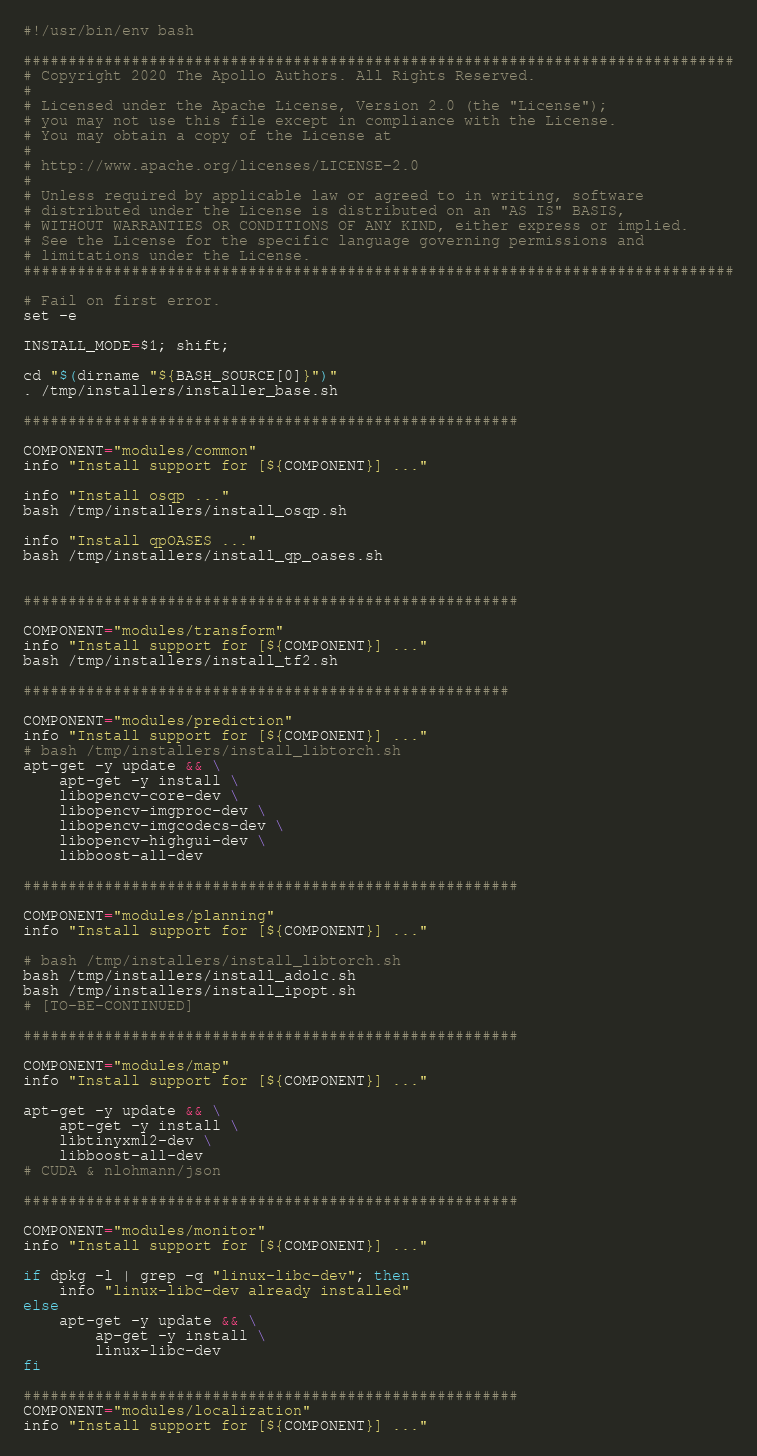<code> <loc_0><loc_0><loc_500><loc_500><_Bash_>#!/usr/bin/env bash

###############################################################################
# Copyright 2020 The Apollo Authors. All Rights Reserved.
#
# Licensed under the Apache License, Version 2.0 (the "License");
# you may not use this file except in compliance with the License.
# You may obtain a copy of the License at
#
# http://www.apache.org/licenses/LICENSE-2.0
#
# Unless required by applicable law or agreed to in writing, software
# distributed under the License is distributed on an "AS IS" BASIS,
# WITHOUT WARRANTIES OR CONDITIONS OF ANY KIND, either express or implied.
# See the License for the specific language governing permissions and
# limitations under the License.
###############################################################################

# Fail on first error.
set -e

INSTALL_MODE=$1; shift;

cd "$(dirname "${BASH_SOURCE[0]}")"
. /tmp/installers/installer_base.sh

#######################################################

COMPONENT="modules/common"
info "Install support for [${COMPONENT}] ..."

info "Install osqp ..."
bash /tmp/installers/install_osqp.sh

info "Install qpOASES ..."
bash /tmp/installers/install_qp_oases.sh


#######################################################

COMPONENT="modules/transform"
info "Install support for [${COMPONENT}] ..."
bash /tmp/installers/install_tf2.sh

######################################################

COMPONENT="modules/prediction"
info "Install support for [${COMPONENT}] ..."
# bash /tmp/installers/install_libtorch.sh
apt-get -y update && \
    apt-get -y install \
    libopencv-core-dev \
    libopencv-imgproc-dev \
    libopencv-imgcodecs-dev \
    libopencv-highgui-dev \
    libboost-all-dev

#######################################################

COMPONENT="modules/planning"
info "Install support for [${COMPONENT}] ..."

# bash /tmp/installers/install_libtorch.sh
bash /tmp/installers/install_adolc.sh
bash /tmp/installers/install_ipopt.sh
# [TO-BE-CONTINUED]

#######################################################

COMPONENT="modules/map"
info "Install support for [${COMPONENT}] ..."

apt-get -y update && \
    apt-get -y install \
    libtinyxml2-dev \
    libboost-all-dev
# CUDA & nlohmann/json

#######################################################

COMPONENT="modules/monitor"
info "Install support for [${COMPONENT}] ..."

if dpkg -l | grep -q "linux-libc-dev"; then
    info "linux-libc-dev already installed"
else
    apt-get -y update && \
        ap-get -y install \
        linux-libc-dev
fi

#######################################################
COMPONENT="modules/localization"
info "Install support for [${COMPONENT}] ..."
</code> 